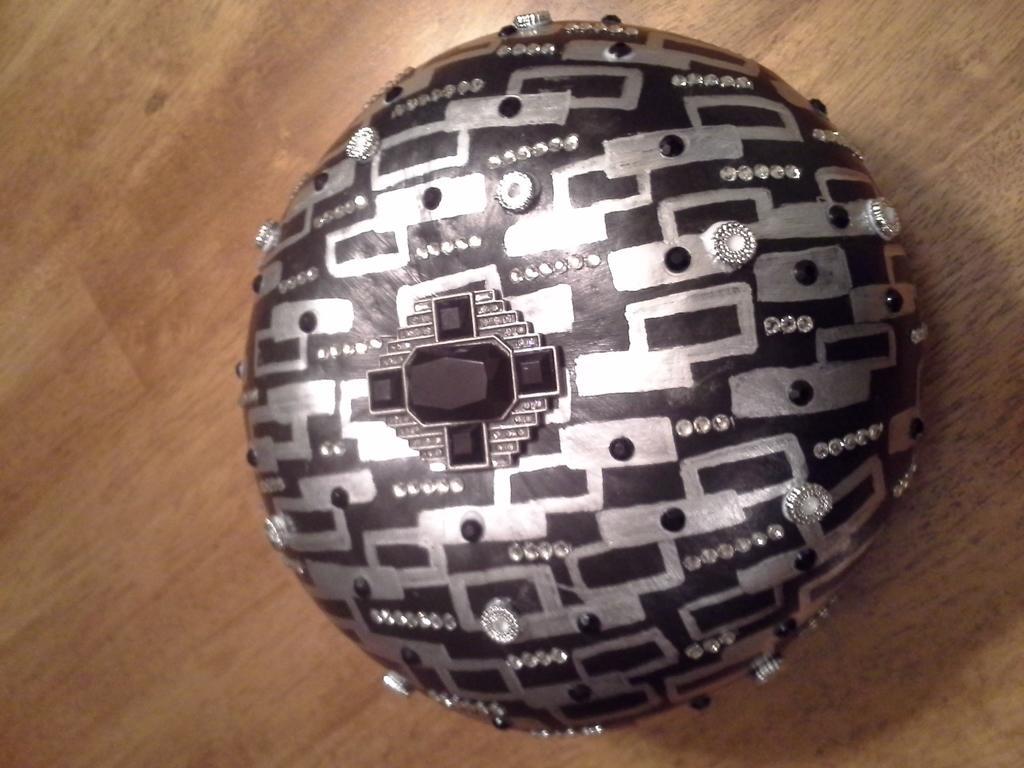Can you describe this image briefly? In this image I can see an object on the brown color surface. The object is in black and silver color. And I can see some stones on it. 